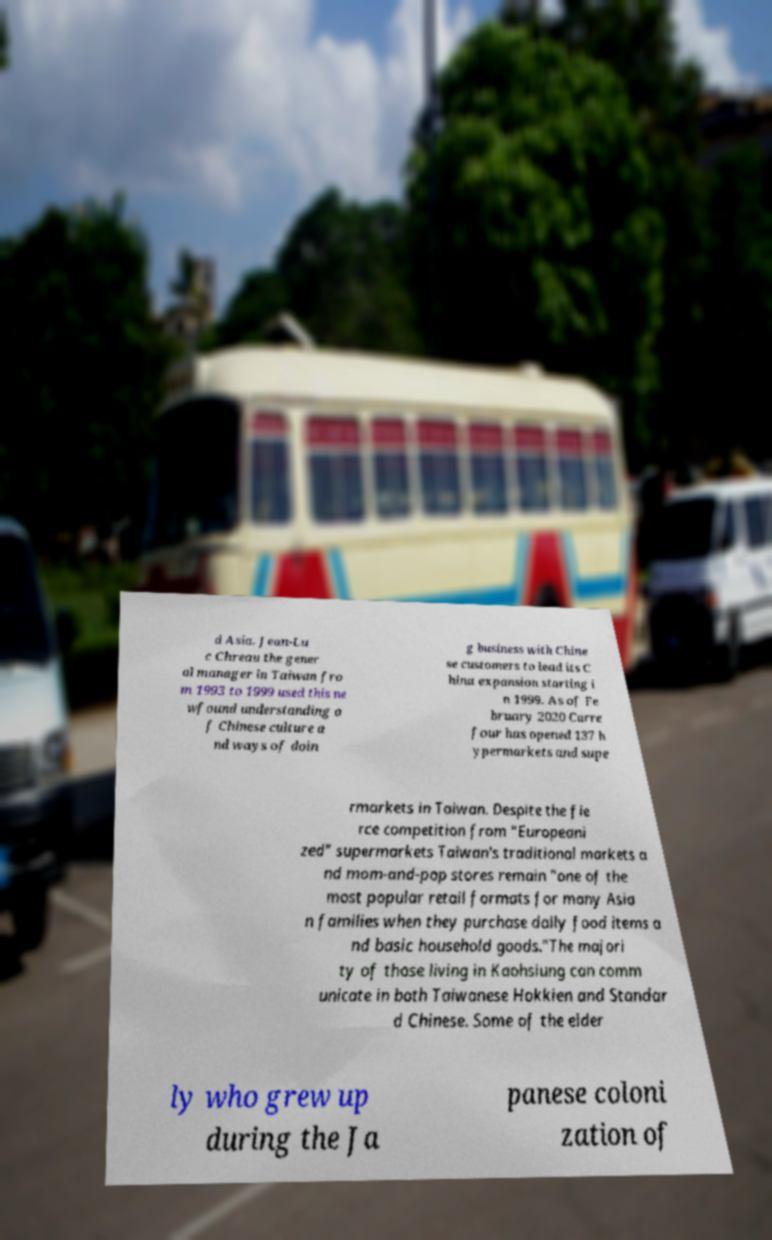What messages or text are displayed in this image? I need them in a readable, typed format. d Asia. Jean-Lu c Chreau the gener al manager in Taiwan fro m 1993 to 1999 used this ne wfound understanding o f Chinese culture a nd ways of doin g business with Chine se customers to lead its C hina expansion starting i n 1999. As of Fe bruary 2020 Carre four has opened 137 h ypermarkets and supe rmarkets in Taiwan. Despite the fie rce competition from "Europeani zed" supermarkets Taiwan's traditional markets a nd mom-and-pop stores remain "one of the most popular retail formats for many Asia n families when they purchase daily food items a nd basic household goods."The majori ty of those living in Kaohsiung can comm unicate in both Taiwanese Hokkien and Standar d Chinese. Some of the elder ly who grew up during the Ja panese coloni zation of 